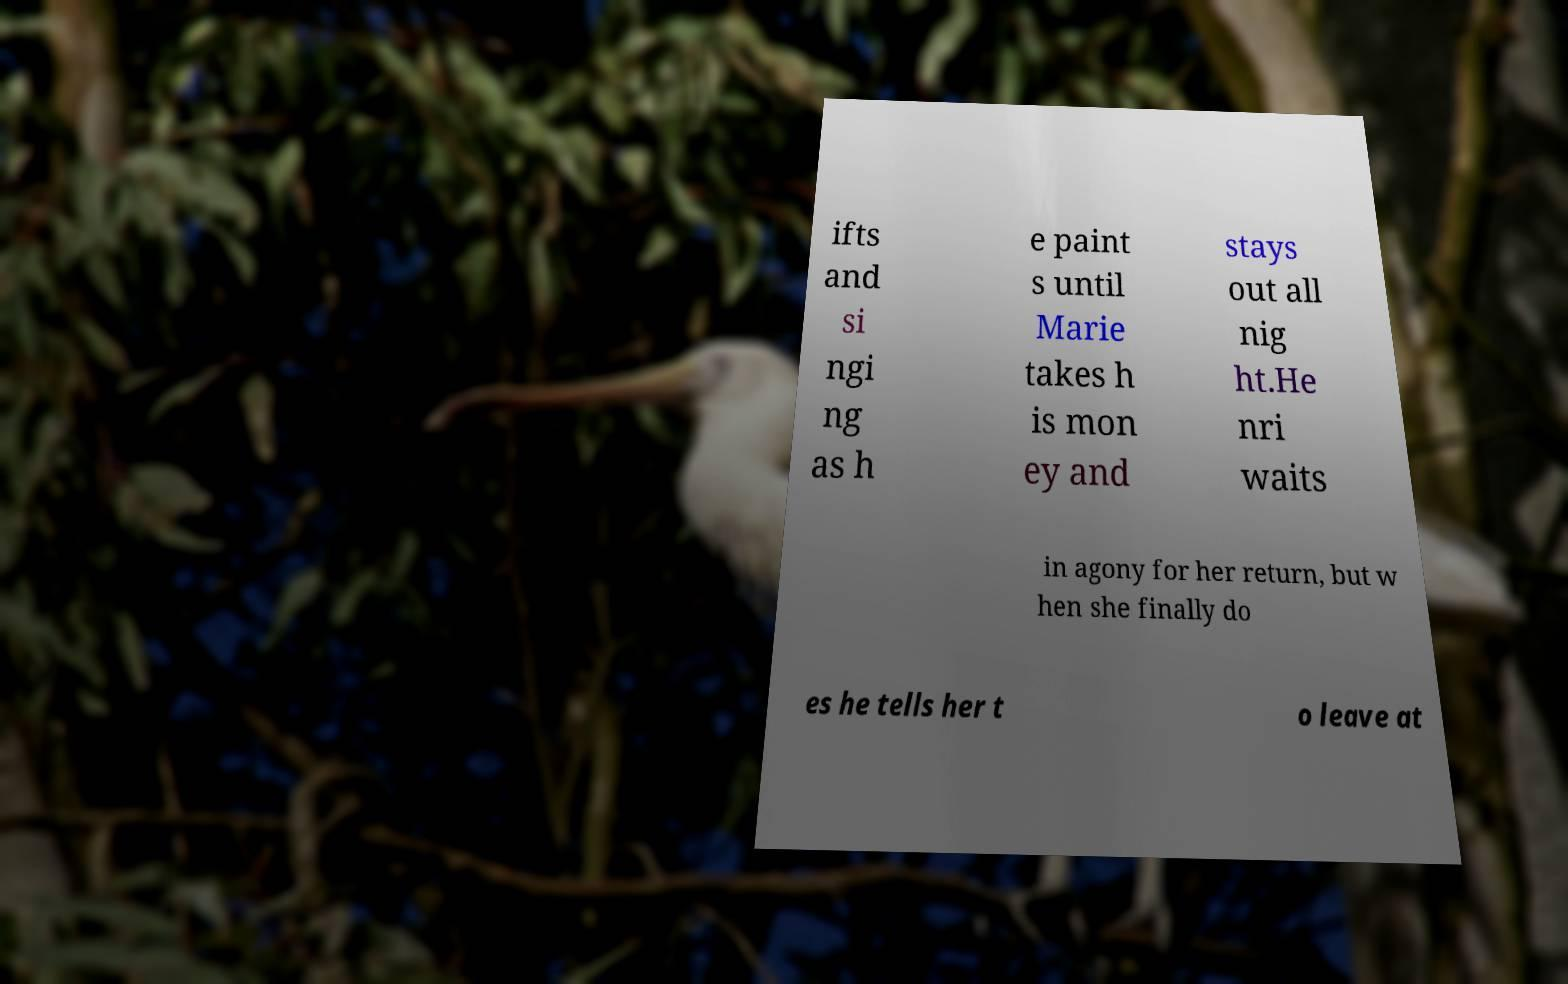There's text embedded in this image that I need extracted. Can you transcribe it verbatim? ifts and si ngi ng as h e paint s until Marie takes h is mon ey and stays out all nig ht.He nri waits in agony for her return, but w hen she finally do es he tells her t o leave at 